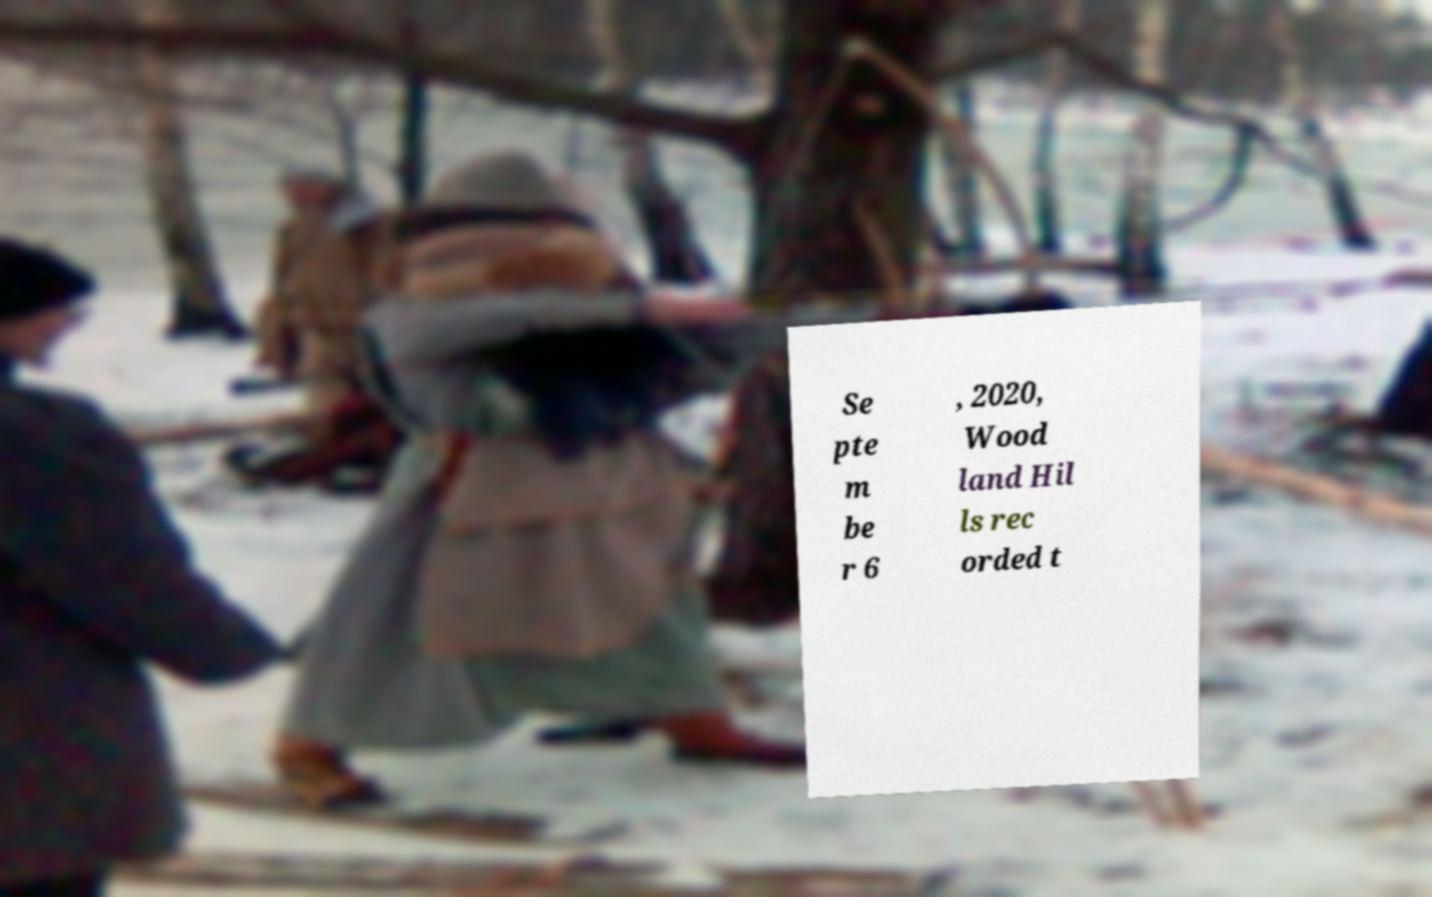Can you read and provide the text displayed in the image?This photo seems to have some interesting text. Can you extract and type it out for me? Se pte m be r 6 , 2020, Wood land Hil ls rec orded t 